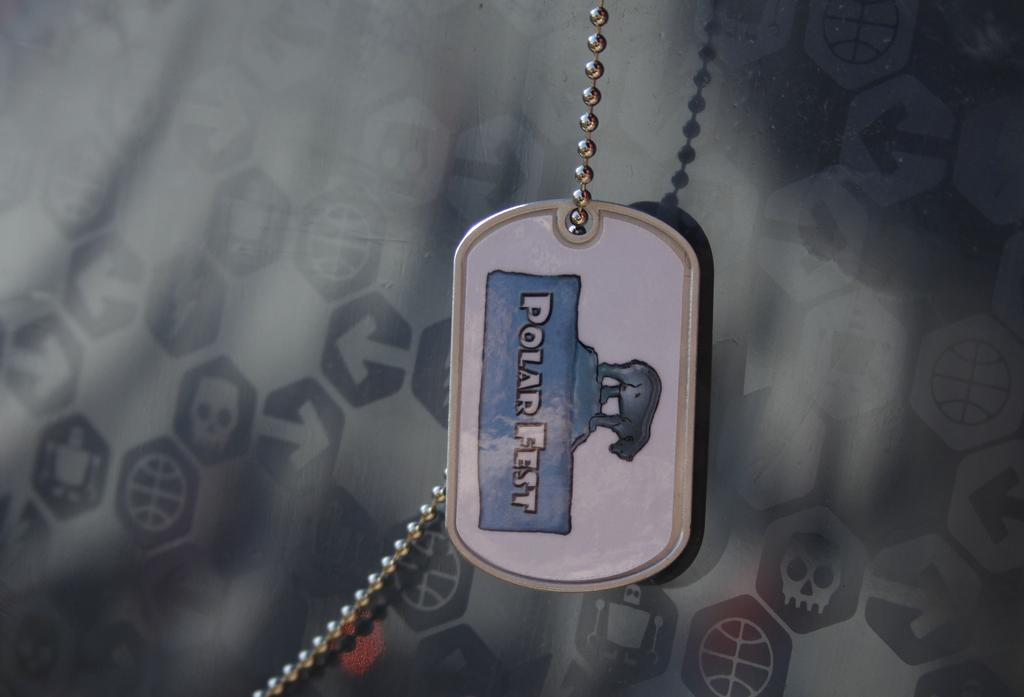What is the main subject of the image? The main subject of the image is a locket of a polar bear on a chain. What types of symbols can be seen in the background of the image? There are symbols of skulls, robots, arrows, and balls in the background of the image. What type of mist can be seen surrounding the locket in the image? There is no mist present in the image; it only features a locket of a polar bear on a chain and various symbols in the background. 